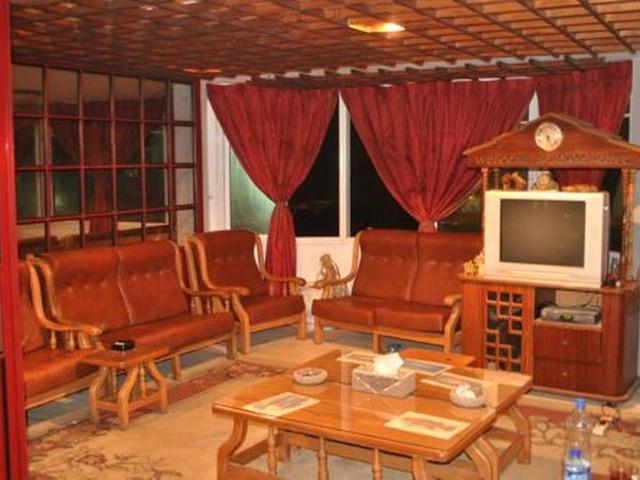How many windows are there?
Concise answer only. 3. Is this room red?
Keep it brief. No. There is seating for how many people in this room?
Concise answer only. 6. What color is this room?
Keep it brief. Red. What color are the curtains?
Give a very brief answer. Red. 